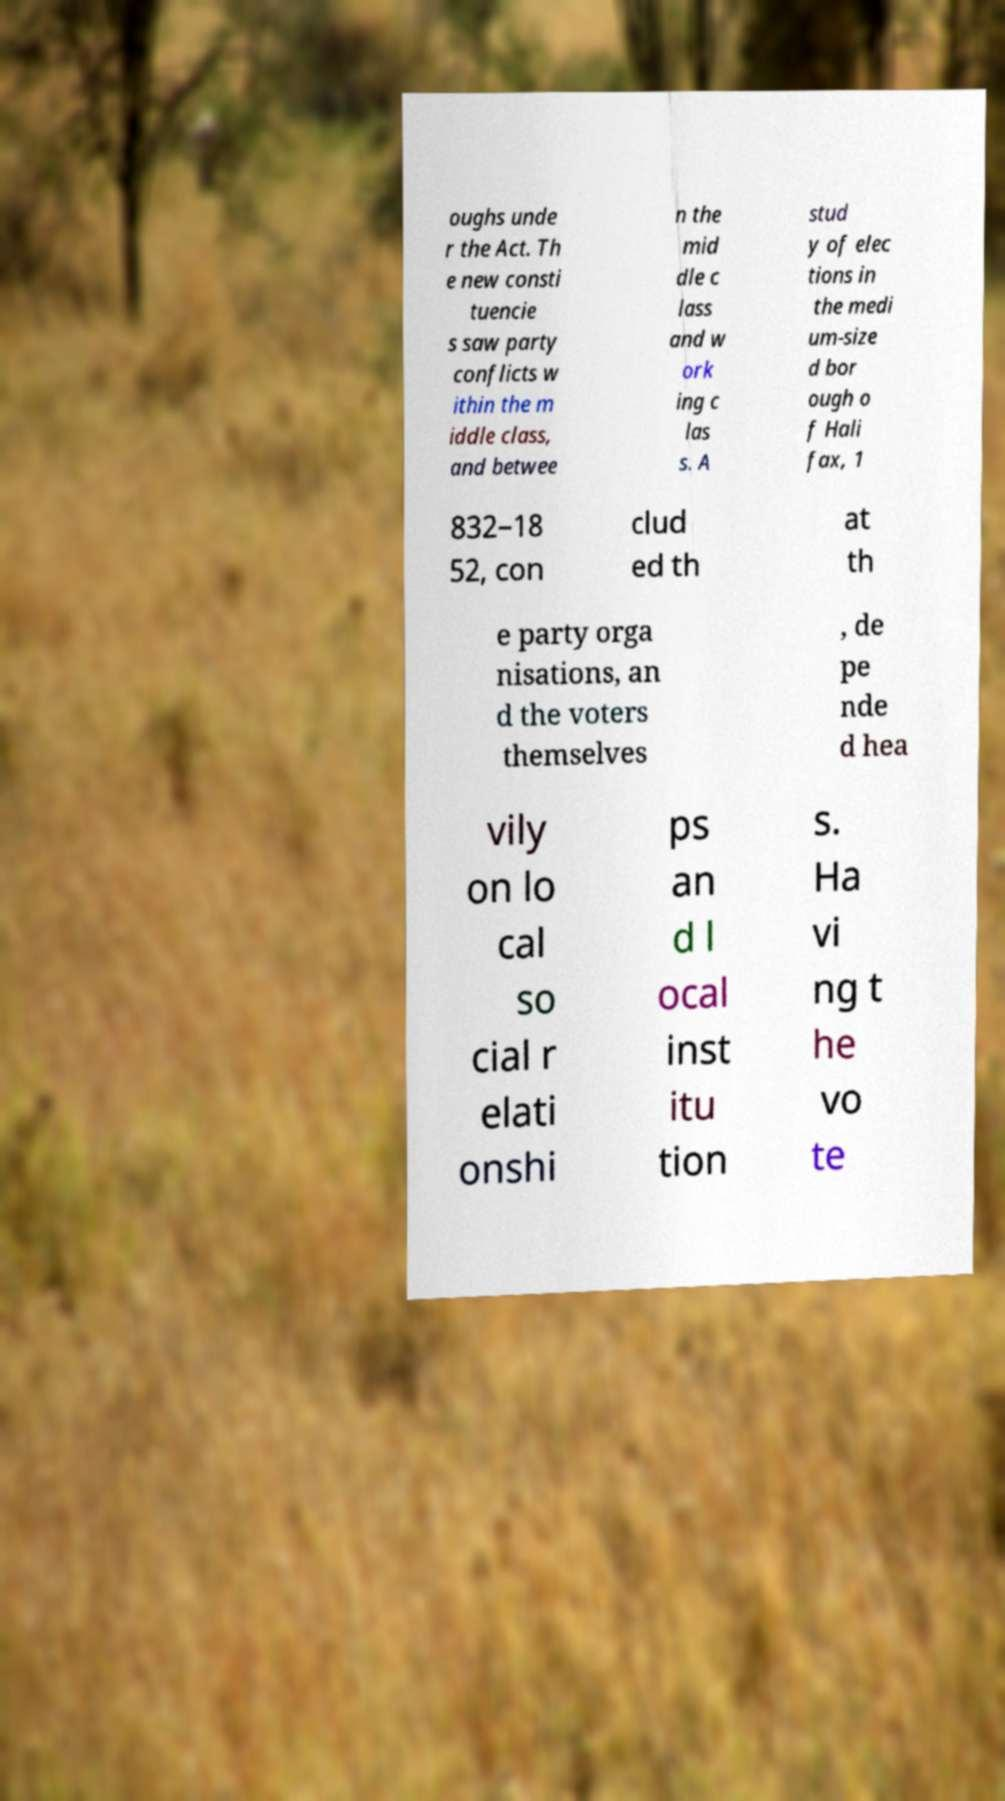Can you read and provide the text displayed in the image?This photo seems to have some interesting text. Can you extract and type it out for me? oughs unde r the Act. Th e new consti tuencie s saw party conflicts w ithin the m iddle class, and betwee n the mid dle c lass and w ork ing c las s. A stud y of elec tions in the medi um-size d bor ough o f Hali fax, 1 832–18 52, con clud ed th at th e party orga nisations, an d the voters themselves , de pe nde d hea vily on lo cal so cial r elati onshi ps an d l ocal inst itu tion s. Ha vi ng t he vo te 